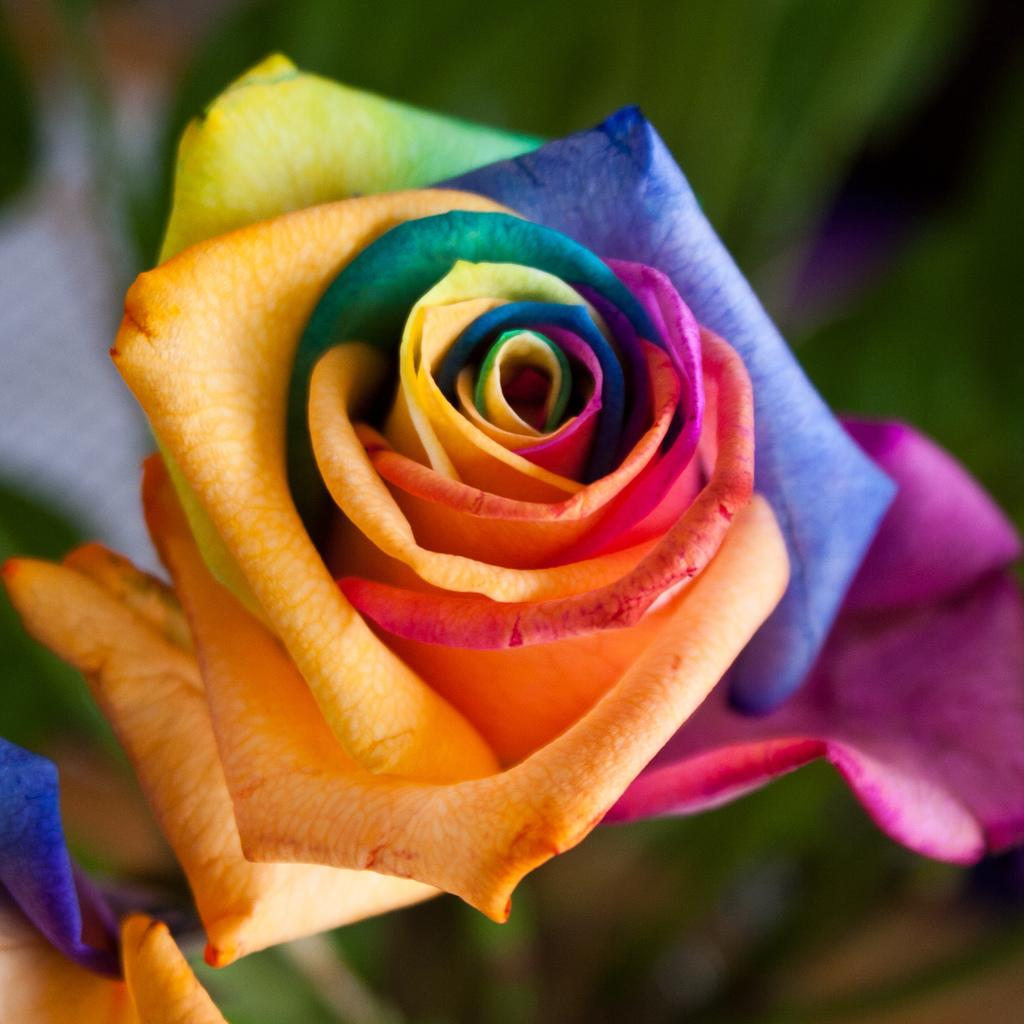What is the main subject of the image? There is a colorful flower in the image. Can you describe the background of the image? The background of the image is blurry. How many friends are holding umbrellas in the image? There are no friends or umbrellas present in the image; it features a colorful flower with a blurry background. 